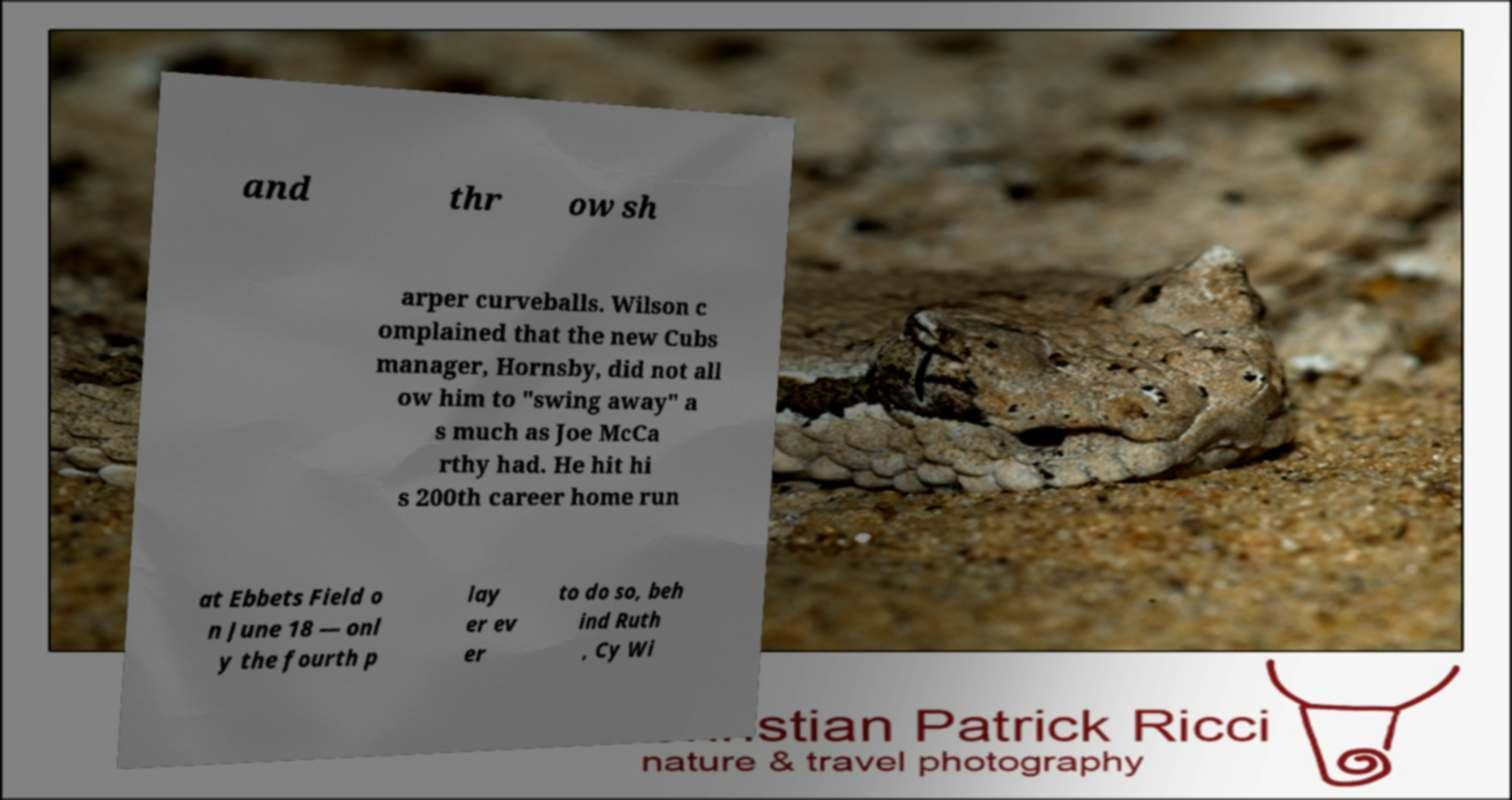Can you read and provide the text displayed in the image?This photo seems to have some interesting text. Can you extract and type it out for me? and thr ow sh arper curveballs. Wilson c omplained that the new Cubs manager, Hornsby, did not all ow him to "swing away" a s much as Joe McCa rthy had. He hit hi s 200th career home run at Ebbets Field o n June 18 — onl y the fourth p lay er ev er to do so, beh ind Ruth , Cy Wi 